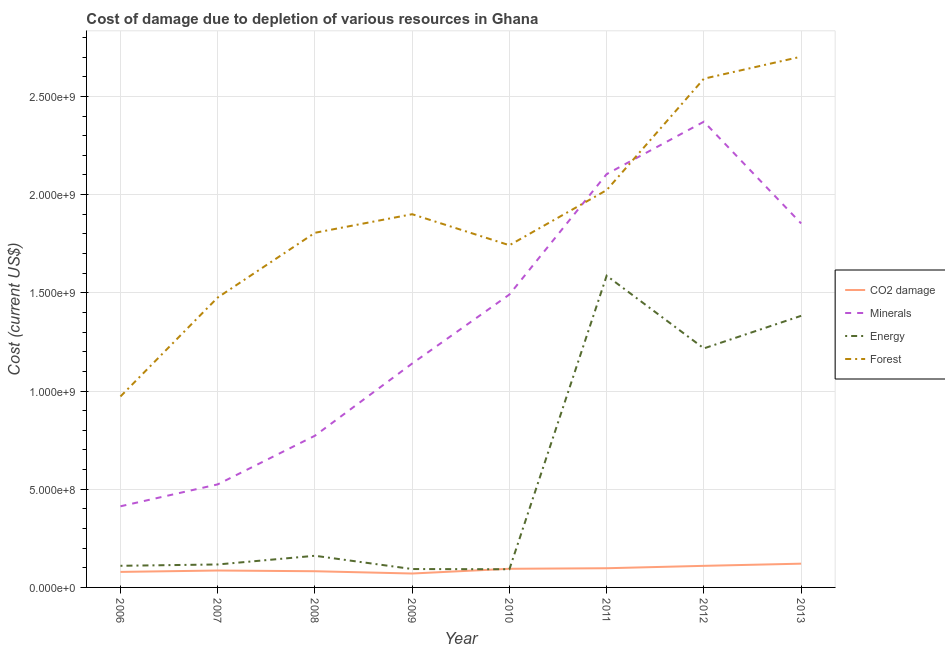How many different coloured lines are there?
Your answer should be compact. 4. Does the line corresponding to cost of damage due to depletion of coal intersect with the line corresponding to cost of damage due to depletion of forests?
Provide a succinct answer. No. Is the number of lines equal to the number of legend labels?
Provide a succinct answer. Yes. What is the cost of damage due to depletion of forests in 2013?
Provide a succinct answer. 2.70e+09. Across all years, what is the maximum cost of damage due to depletion of forests?
Your answer should be very brief. 2.70e+09. Across all years, what is the minimum cost of damage due to depletion of forests?
Provide a short and direct response. 9.72e+08. In which year was the cost of damage due to depletion of forests minimum?
Provide a succinct answer. 2006. What is the total cost of damage due to depletion of energy in the graph?
Provide a succinct answer. 4.76e+09. What is the difference between the cost of damage due to depletion of forests in 2008 and that in 2013?
Provide a short and direct response. -8.97e+08. What is the difference between the cost of damage due to depletion of minerals in 2006 and the cost of damage due to depletion of coal in 2013?
Your answer should be compact. 2.92e+08. What is the average cost of damage due to depletion of minerals per year?
Offer a terse response. 1.33e+09. In the year 2006, what is the difference between the cost of damage due to depletion of energy and cost of damage due to depletion of minerals?
Your response must be concise. -3.03e+08. What is the ratio of the cost of damage due to depletion of energy in 2008 to that in 2009?
Your answer should be compact. 1.72. Is the difference between the cost of damage due to depletion of coal in 2011 and 2013 greater than the difference between the cost of damage due to depletion of forests in 2011 and 2013?
Offer a terse response. Yes. What is the difference between the highest and the second highest cost of damage due to depletion of minerals?
Provide a short and direct response. 2.67e+08. What is the difference between the highest and the lowest cost of damage due to depletion of minerals?
Make the answer very short. 1.96e+09. Is the sum of the cost of damage due to depletion of energy in 2010 and 2012 greater than the maximum cost of damage due to depletion of forests across all years?
Your answer should be compact. No. Is it the case that in every year, the sum of the cost of damage due to depletion of energy and cost of damage due to depletion of minerals is greater than the sum of cost of damage due to depletion of coal and cost of damage due to depletion of forests?
Ensure brevity in your answer.  No. Is the cost of damage due to depletion of minerals strictly greater than the cost of damage due to depletion of coal over the years?
Your answer should be compact. Yes. Is the cost of damage due to depletion of minerals strictly less than the cost of damage due to depletion of energy over the years?
Provide a succinct answer. No. How many lines are there?
Give a very brief answer. 4. What is the difference between two consecutive major ticks on the Y-axis?
Give a very brief answer. 5.00e+08. Does the graph contain any zero values?
Provide a short and direct response. No. Does the graph contain grids?
Provide a short and direct response. Yes. Where does the legend appear in the graph?
Provide a succinct answer. Center right. How many legend labels are there?
Your answer should be very brief. 4. How are the legend labels stacked?
Your answer should be compact. Vertical. What is the title of the graph?
Ensure brevity in your answer.  Cost of damage due to depletion of various resources in Ghana . Does "Goods and services" appear as one of the legend labels in the graph?
Ensure brevity in your answer.  No. What is the label or title of the X-axis?
Ensure brevity in your answer.  Year. What is the label or title of the Y-axis?
Your answer should be compact. Cost (current US$). What is the Cost (current US$) in CO2 damage in 2006?
Provide a succinct answer. 7.90e+07. What is the Cost (current US$) of Minerals in 2006?
Your answer should be compact. 4.13e+08. What is the Cost (current US$) of Energy in 2006?
Provide a succinct answer. 1.10e+08. What is the Cost (current US$) of Forest in 2006?
Keep it short and to the point. 9.72e+08. What is the Cost (current US$) in CO2 damage in 2007?
Your response must be concise. 8.61e+07. What is the Cost (current US$) in Minerals in 2007?
Offer a terse response. 5.25e+08. What is the Cost (current US$) of Energy in 2007?
Offer a terse response. 1.17e+08. What is the Cost (current US$) of Forest in 2007?
Ensure brevity in your answer.  1.48e+09. What is the Cost (current US$) in CO2 damage in 2008?
Your answer should be very brief. 8.25e+07. What is the Cost (current US$) of Minerals in 2008?
Give a very brief answer. 7.72e+08. What is the Cost (current US$) in Energy in 2008?
Provide a succinct answer. 1.61e+08. What is the Cost (current US$) in Forest in 2008?
Ensure brevity in your answer.  1.81e+09. What is the Cost (current US$) in CO2 damage in 2009?
Your answer should be very brief. 7.08e+07. What is the Cost (current US$) in Minerals in 2009?
Your answer should be compact. 1.14e+09. What is the Cost (current US$) in Energy in 2009?
Your answer should be compact. 9.36e+07. What is the Cost (current US$) in Forest in 2009?
Give a very brief answer. 1.90e+09. What is the Cost (current US$) of CO2 damage in 2010?
Provide a short and direct response. 9.49e+07. What is the Cost (current US$) of Minerals in 2010?
Your answer should be very brief. 1.49e+09. What is the Cost (current US$) in Energy in 2010?
Your answer should be compact. 9.26e+07. What is the Cost (current US$) of Forest in 2010?
Your answer should be very brief. 1.74e+09. What is the Cost (current US$) of CO2 damage in 2011?
Your answer should be very brief. 9.77e+07. What is the Cost (current US$) in Minerals in 2011?
Your answer should be compact. 2.10e+09. What is the Cost (current US$) of Energy in 2011?
Your response must be concise. 1.59e+09. What is the Cost (current US$) in Forest in 2011?
Ensure brevity in your answer.  2.02e+09. What is the Cost (current US$) of CO2 damage in 2012?
Keep it short and to the point. 1.10e+08. What is the Cost (current US$) of Minerals in 2012?
Make the answer very short. 2.37e+09. What is the Cost (current US$) of Energy in 2012?
Provide a succinct answer. 1.22e+09. What is the Cost (current US$) in Forest in 2012?
Provide a succinct answer. 2.59e+09. What is the Cost (current US$) in CO2 damage in 2013?
Offer a very short reply. 1.21e+08. What is the Cost (current US$) in Minerals in 2013?
Offer a very short reply. 1.85e+09. What is the Cost (current US$) in Energy in 2013?
Make the answer very short. 1.38e+09. What is the Cost (current US$) of Forest in 2013?
Your response must be concise. 2.70e+09. Across all years, what is the maximum Cost (current US$) of CO2 damage?
Your response must be concise. 1.21e+08. Across all years, what is the maximum Cost (current US$) in Minerals?
Provide a succinct answer. 2.37e+09. Across all years, what is the maximum Cost (current US$) of Energy?
Offer a terse response. 1.59e+09. Across all years, what is the maximum Cost (current US$) in Forest?
Your response must be concise. 2.70e+09. Across all years, what is the minimum Cost (current US$) in CO2 damage?
Your response must be concise. 7.08e+07. Across all years, what is the minimum Cost (current US$) of Minerals?
Provide a succinct answer. 4.13e+08. Across all years, what is the minimum Cost (current US$) in Energy?
Your answer should be very brief. 9.26e+07. Across all years, what is the minimum Cost (current US$) of Forest?
Provide a short and direct response. 9.72e+08. What is the total Cost (current US$) of CO2 damage in the graph?
Offer a terse response. 7.42e+08. What is the total Cost (current US$) in Minerals in the graph?
Offer a very short reply. 1.07e+1. What is the total Cost (current US$) of Energy in the graph?
Keep it short and to the point. 4.76e+09. What is the total Cost (current US$) of Forest in the graph?
Your response must be concise. 1.52e+1. What is the difference between the Cost (current US$) in CO2 damage in 2006 and that in 2007?
Your answer should be compact. -7.07e+06. What is the difference between the Cost (current US$) of Minerals in 2006 and that in 2007?
Give a very brief answer. -1.12e+08. What is the difference between the Cost (current US$) in Energy in 2006 and that in 2007?
Give a very brief answer. -6.77e+06. What is the difference between the Cost (current US$) of Forest in 2006 and that in 2007?
Provide a short and direct response. -5.04e+08. What is the difference between the Cost (current US$) of CO2 damage in 2006 and that in 2008?
Ensure brevity in your answer.  -3.46e+06. What is the difference between the Cost (current US$) in Minerals in 2006 and that in 2008?
Ensure brevity in your answer.  -3.59e+08. What is the difference between the Cost (current US$) in Energy in 2006 and that in 2008?
Ensure brevity in your answer.  -5.10e+07. What is the difference between the Cost (current US$) of Forest in 2006 and that in 2008?
Offer a very short reply. -8.33e+08. What is the difference between the Cost (current US$) of CO2 damage in 2006 and that in 2009?
Provide a succinct answer. 8.18e+06. What is the difference between the Cost (current US$) of Minerals in 2006 and that in 2009?
Provide a succinct answer. -7.27e+08. What is the difference between the Cost (current US$) of Energy in 2006 and that in 2009?
Give a very brief answer. 1.65e+07. What is the difference between the Cost (current US$) in Forest in 2006 and that in 2009?
Provide a short and direct response. -9.28e+08. What is the difference between the Cost (current US$) of CO2 damage in 2006 and that in 2010?
Provide a succinct answer. -1.59e+07. What is the difference between the Cost (current US$) of Minerals in 2006 and that in 2010?
Your response must be concise. -1.08e+09. What is the difference between the Cost (current US$) in Energy in 2006 and that in 2010?
Provide a succinct answer. 1.76e+07. What is the difference between the Cost (current US$) in Forest in 2006 and that in 2010?
Provide a succinct answer. -7.70e+08. What is the difference between the Cost (current US$) in CO2 damage in 2006 and that in 2011?
Offer a terse response. -1.87e+07. What is the difference between the Cost (current US$) of Minerals in 2006 and that in 2011?
Make the answer very short. -1.69e+09. What is the difference between the Cost (current US$) in Energy in 2006 and that in 2011?
Make the answer very short. -1.48e+09. What is the difference between the Cost (current US$) in Forest in 2006 and that in 2011?
Make the answer very short. -1.05e+09. What is the difference between the Cost (current US$) of CO2 damage in 2006 and that in 2012?
Offer a very short reply. -3.08e+07. What is the difference between the Cost (current US$) in Minerals in 2006 and that in 2012?
Offer a terse response. -1.96e+09. What is the difference between the Cost (current US$) of Energy in 2006 and that in 2012?
Your answer should be very brief. -1.11e+09. What is the difference between the Cost (current US$) in Forest in 2006 and that in 2012?
Provide a succinct answer. -1.62e+09. What is the difference between the Cost (current US$) of CO2 damage in 2006 and that in 2013?
Make the answer very short. -4.19e+07. What is the difference between the Cost (current US$) in Minerals in 2006 and that in 2013?
Your answer should be very brief. -1.44e+09. What is the difference between the Cost (current US$) of Energy in 2006 and that in 2013?
Make the answer very short. -1.27e+09. What is the difference between the Cost (current US$) in Forest in 2006 and that in 2013?
Provide a succinct answer. -1.73e+09. What is the difference between the Cost (current US$) in CO2 damage in 2007 and that in 2008?
Offer a very short reply. 3.61e+06. What is the difference between the Cost (current US$) in Minerals in 2007 and that in 2008?
Make the answer very short. -2.48e+08. What is the difference between the Cost (current US$) of Energy in 2007 and that in 2008?
Keep it short and to the point. -4.42e+07. What is the difference between the Cost (current US$) of Forest in 2007 and that in 2008?
Offer a terse response. -3.30e+08. What is the difference between the Cost (current US$) in CO2 damage in 2007 and that in 2009?
Give a very brief answer. 1.52e+07. What is the difference between the Cost (current US$) in Minerals in 2007 and that in 2009?
Offer a very short reply. -6.15e+08. What is the difference between the Cost (current US$) of Energy in 2007 and that in 2009?
Your answer should be very brief. 2.33e+07. What is the difference between the Cost (current US$) of Forest in 2007 and that in 2009?
Your answer should be very brief. -4.24e+08. What is the difference between the Cost (current US$) in CO2 damage in 2007 and that in 2010?
Your response must be concise. -8.87e+06. What is the difference between the Cost (current US$) of Minerals in 2007 and that in 2010?
Provide a short and direct response. -9.67e+08. What is the difference between the Cost (current US$) in Energy in 2007 and that in 2010?
Offer a very short reply. 2.43e+07. What is the difference between the Cost (current US$) of Forest in 2007 and that in 2010?
Your response must be concise. -2.66e+08. What is the difference between the Cost (current US$) in CO2 damage in 2007 and that in 2011?
Offer a terse response. -1.16e+07. What is the difference between the Cost (current US$) of Minerals in 2007 and that in 2011?
Ensure brevity in your answer.  -1.58e+09. What is the difference between the Cost (current US$) of Energy in 2007 and that in 2011?
Your answer should be very brief. -1.47e+09. What is the difference between the Cost (current US$) in Forest in 2007 and that in 2011?
Ensure brevity in your answer.  -5.47e+08. What is the difference between the Cost (current US$) of CO2 damage in 2007 and that in 2012?
Your response must be concise. -2.38e+07. What is the difference between the Cost (current US$) in Minerals in 2007 and that in 2012?
Give a very brief answer. -1.85e+09. What is the difference between the Cost (current US$) in Energy in 2007 and that in 2012?
Keep it short and to the point. -1.10e+09. What is the difference between the Cost (current US$) in Forest in 2007 and that in 2012?
Your answer should be very brief. -1.11e+09. What is the difference between the Cost (current US$) of CO2 damage in 2007 and that in 2013?
Keep it short and to the point. -3.48e+07. What is the difference between the Cost (current US$) in Minerals in 2007 and that in 2013?
Keep it short and to the point. -1.33e+09. What is the difference between the Cost (current US$) of Energy in 2007 and that in 2013?
Provide a succinct answer. -1.27e+09. What is the difference between the Cost (current US$) in Forest in 2007 and that in 2013?
Your answer should be compact. -1.23e+09. What is the difference between the Cost (current US$) of CO2 damage in 2008 and that in 2009?
Keep it short and to the point. 1.16e+07. What is the difference between the Cost (current US$) of Minerals in 2008 and that in 2009?
Give a very brief answer. -3.68e+08. What is the difference between the Cost (current US$) in Energy in 2008 and that in 2009?
Ensure brevity in your answer.  6.75e+07. What is the difference between the Cost (current US$) of Forest in 2008 and that in 2009?
Your answer should be very brief. -9.46e+07. What is the difference between the Cost (current US$) in CO2 damage in 2008 and that in 2010?
Provide a succinct answer. -1.25e+07. What is the difference between the Cost (current US$) in Minerals in 2008 and that in 2010?
Provide a succinct answer. -7.19e+08. What is the difference between the Cost (current US$) of Energy in 2008 and that in 2010?
Provide a short and direct response. 6.85e+07. What is the difference between the Cost (current US$) in Forest in 2008 and that in 2010?
Provide a short and direct response. 6.34e+07. What is the difference between the Cost (current US$) of CO2 damage in 2008 and that in 2011?
Your answer should be compact. -1.52e+07. What is the difference between the Cost (current US$) in Minerals in 2008 and that in 2011?
Ensure brevity in your answer.  -1.33e+09. What is the difference between the Cost (current US$) of Energy in 2008 and that in 2011?
Offer a very short reply. -1.43e+09. What is the difference between the Cost (current US$) of Forest in 2008 and that in 2011?
Give a very brief answer. -2.17e+08. What is the difference between the Cost (current US$) in CO2 damage in 2008 and that in 2012?
Keep it short and to the point. -2.74e+07. What is the difference between the Cost (current US$) of Minerals in 2008 and that in 2012?
Your answer should be very brief. -1.60e+09. What is the difference between the Cost (current US$) of Energy in 2008 and that in 2012?
Offer a terse response. -1.06e+09. What is the difference between the Cost (current US$) in Forest in 2008 and that in 2012?
Offer a very short reply. -7.84e+08. What is the difference between the Cost (current US$) of CO2 damage in 2008 and that in 2013?
Your response must be concise. -3.85e+07. What is the difference between the Cost (current US$) of Minerals in 2008 and that in 2013?
Offer a terse response. -1.08e+09. What is the difference between the Cost (current US$) of Energy in 2008 and that in 2013?
Provide a short and direct response. -1.22e+09. What is the difference between the Cost (current US$) in Forest in 2008 and that in 2013?
Keep it short and to the point. -8.97e+08. What is the difference between the Cost (current US$) of CO2 damage in 2009 and that in 2010?
Your answer should be compact. -2.41e+07. What is the difference between the Cost (current US$) in Minerals in 2009 and that in 2010?
Provide a short and direct response. -3.51e+08. What is the difference between the Cost (current US$) in Energy in 2009 and that in 2010?
Your answer should be compact. 1.07e+06. What is the difference between the Cost (current US$) in Forest in 2009 and that in 2010?
Provide a short and direct response. 1.58e+08. What is the difference between the Cost (current US$) in CO2 damage in 2009 and that in 2011?
Offer a terse response. -2.69e+07. What is the difference between the Cost (current US$) of Minerals in 2009 and that in 2011?
Offer a very short reply. -9.64e+08. What is the difference between the Cost (current US$) in Energy in 2009 and that in 2011?
Give a very brief answer. -1.49e+09. What is the difference between the Cost (current US$) in Forest in 2009 and that in 2011?
Offer a very short reply. -1.23e+08. What is the difference between the Cost (current US$) of CO2 damage in 2009 and that in 2012?
Provide a short and direct response. -3.90e+07. What is the difference between the Cost (current US$) of Minerals in 2009 and that in 2012?
Make the answer very short. -1.23e+09. What is the difference between the Cost (current US$) of Energy in 2009 and that in 2012?
Offer a very short reply. -1.12e+09. What is the difference between the Cost (current US$) of Forest in 2009 and that in 2012?
Make the answer very short. -6.90e+08. What is the difference between the Cost (current US$) in CO2 damage in 2009 and that in 2013?
Provide a succinct answer. -5.01e+07. What is the difference between the Cost (current US$) of Minerals in 2009 and that in 2013?
Offer a terse response. -7.13e+08. What is the difference between the Cost (current US$) of Energy in 2009 and that in 2013?
Make the answer very short. -1.29e+09. What is the difference between the Cost (current US$) in Forest in 2009 and that in 2013?
Provide a short and direct response. -8.02e+08. What is the difference between the Cost (current US$) in CO2 damage in 2010 and that in 2011?
Make the answer very short. -2.77e+06. What is the difference between the Cost (current US$) in Minerals in 2010 and that in 2011?
Offer a very short reply. -6.13e+08. What is the difference between the Cost (current US$) in Energy in 2010 and that in 2011?
Your answer should be very brief. -1.49e+09. What is the difference between the Cost (current US$) of Forest in 2010 and that in 2011?
Give a very brief answer. -2.81e+08. What is the difference between the Cost (current US$) in CO2 damage in 2010 and that in 2012?
Keep it short and to the point. -1.49e+07. What is the difference between the Cost (current US$) of Minerals in 2010 and that in 2012?
Give a very brief answer. -8.80e+08. What is the difference between the Cost (current US$) of Energy in 2010 and that in 2012?
Offer a very short reply. -1.12e+09. What is the difference between the Cost (current US$) in Forest in 2010 and that in 2012?
Your answer should be compact. -8.48e+08. What is the difference between the Cost (current US$) in CO2 damage in 2010 and that in 2013?
Offer a terse response. -2.60e+07. What is the difference between the Cost (current US$) in Minerals in 2010 and that in 2013?
Provide a succinct answer. -3.62e+08. What is the difference between the Cost (current US$) of Energy in 2010 and that in 2013?
Your answer should be compact. -1.29e+09. What is the difference between the Cost (current US$) of Forest in 2010 and that in 2013?
Ensure brevity in your answer.  -9.60e+08. What is the difference between the Cost (current US$) in CO2 damage in 2011 and that in 2012?
Your answer should be compact. -1.21e+07. What is the difference between the Cost (current US$) of Minerals in 2011 and that in 2012?
Offer a very short reply. -2.67e+08. What is the difference between the Cost (current US$) of Energy in 2011 and that in 2012?
Offer a terse response. 3.70e+08. What is the difference between the Cost (current US$) of Forest in 2011 and that in 2012?
Ensure brevity in your answer.  -5.67e+08. What is the difference between the Cost (current US$) of CO2 damage in 2011 and that in 2013?
Provide a succinct answer. -2.32e+07. What is the difference between the Cost (current US$) of Minerals in 2011 and that in 2013?
Keep it short and to the point. 2.51e+08. What is the difference between the Cost (current US$) of Energy in 2011 and that in 2013?
Provide a short and direct response. 2.04e+08. What is the difference between the Cost (current US$) in Forest in 2011 and that in 2013?
Provide a succinct answer. -6.79e+08. What is the difference between the Cost (current US$) in CO2 damage in 2012 and that in 2013?
Offer a terse response. -1.11e+07. What is the difference between the Cost (current US$) of Minerals in 2012 and that in 2013?
Provide a succinct answer. 5.18e+08. What is the difference between the Cost (current US$) in Energy in 2012 and that in 2013?
Your response must be concise. -1.66e+08. What is the difference between the Cost (current US$) in Forest in 2012 and that in 2013?
Offer a terse response. -1.12e+08. What is the difference between the Cost (current US$) in CO2 damage in 2006 and the Cost (current US$) in Minerals in 2007?
Provide a short and direct response. -4.46e+08. What is the difference between the Cost (current US$) of CO2 damage in 2006 and the Cost (current US$) of Energy in 2007?
Your response must be concise. -3.79e+07. What is the difference between the Cost (current US$) of CO2 damage in 2006 and the Cost (current US$) of Forest in 2007?
Your response must be concise. -1.40e+09. What is the difference between the Cost (current US$) in Minerals in 2006 and the Cost (current US$) in Energy in 2007?
Make the answer very short. 2.96e+08. What is the difference between the Cost (current US$) in Minerals in 2006 and the Cost (current US$) in Forest in 2007?
Ensure brevity in your answer.  -1.06e+09. What is the difference between the Cost (current US$) of Energy in 2006 and the Cost (current US$) of Forest in 2007?
Your answer should be compact. -1.37e+09. What is the difference between the Cost (current US$) of CO2 damage in 2006 and the Cost (current US$) of Minerals in 2008?
Provide a short and direct response. -6.93e+08. What is the difference between the Cost (current US$) of CO2 damage in 2006 and the Cost (current US$) of Energy in 2008?
Your answer should be compact. -8.21e+07. What is the difference between the Cost (current US$) of CO2 damage in 2006 and the Cost (current US$) of Forest in 2008?
Your answer should be compact. -1.73e+09. What is the difference between the Cost (current US$) of Minerals in 2006 and the Cost (current US$) of Energy in 2008?
Ensure brevity in your answer.  2.52e+08. What is the difference between the Cost (current US$) in Minerals in 2006 and the Cost (current US$) in Forest in 2008?
Your answer should be very brief. -1.39e+09. What is the difference between the Cost (current US$) in Energy in 2006 and the Cost (current US$) in Forest in 2008?
Provide a short and direct response. -1.70e+09. What is the difference between the Cost (current US$) in CO2 damage in 2006 and the Cost (current US$) in Minerals in 2009?
Make the answer very short. -1.06e+09. What is the difference between the Cost (current US$) of CO2 damage in 2006 and the Cost (current US$) of Energy in 2009?
Your answer should be compact. -1.46e+07. What is the difference between the Cost (current US$) of CO2 damage in 2006 and the Cost (current US$) of Forest in 2009?
Provide a succinct answer. -1.82e+09. What is the difference between the Cost (current US$) in Minerals in 2006 and the Cost (current US$) in Energy in 2009?
Your answer should be compact. 3.19e+08. What is the difference between the Cost (current US$) of Minerals in 2006 and the Cost (current US$) of Forest in 2009?
Provide a succinct answer. -1.49e+09. What is the difference between the Cost (current US$) of Energy in 2006 and the Cost (current US$) of Forest in 2009?
Provide a succinct answer. -1.79e+09. What is the difference between the Cost (current US$) of CO2 damage in 2006 and the Cost (current US$) of Minerals in 2010?
Provide a short and direct response. -1.41e+09. What is the difference between the Cost (current US$) in CO2 damage in 2006 and the Cost (current US$) in Energy in 2010?
Your answer should be compact. -1.36e+07. What is the difference between the Cost (current US$) of CO2 damage in 2006 and the Cost (current US$) of Forest in 2010?
Make the answer very short. -1.66e+09. What is the difference between the Cost (current US$) of Minerals in 2006 and the Cost (current US$) of Energy in 2010?
Keep it short and to the point. 3.20e+08. What is the difference between the Cost (current US$) in Minerals in 2006 and the Cost (current US$) in Forest in 2010?
Make the answer very short. -1.33e+09. What is the difference between the Cost (current US$) in Energy in 2006 and the Cost (current US$) in Forest in 2010?
Ensure brevity in your answer.  -1.63e+09. What is the difference between the Cost (current US$) of CO2 damage in 2006 and the Cost (current US$) of Minerals in 2011?
Provide a short and direct response. -2.03e+09. What is the difference between the Cost (current US$) in CO2 damage in 2006 and the Cost (current US$) in Energy in 2011?
Keep it short and to the point. -1.51e+09. What is the difference between the Cost (current US$) of CO2 damage in 2006 and the Cost (current US$) of Forest in 2011?
Your answer should be compact. -1.94e+09. What is the difference between the Cost (current US$) of Minerals in 2006 and the Cost (current US$) of Energy in 2011?
Provide a succinct answer. -1.17e+09. What is the difference between the Cost (current US$) of Minerals in 2006 and the Cost (current US$) of Forest in 2011?
Your answer should be compact. -1.61e+09. What is the difference between the Cost (current US$) of Energy in 2006 and the Cost (current US$) of Forest in 2011?
Your response must be concise. -1.91e+09. What is the difference between the Cost (current US$) in CO2 damage in 2006 and the Cost (current US$) in Minerals in 2012?
Offer a terse response. -2.29e+09. What is the difference between the Cost (current US$) of CO2 damage in 2006 and the Cost (current US$) of Energy in 2012?
Provide a short and direct response. -1.14e+09. What is the difference between the Cost (current US$) in CO2 damage in 2006 and the Cost (current US$) in Forest in 2012?
Your response must be concise. -2.51e+09. What is the difference between the Cost (current US$) in Minerals in 2006 and the Cost (current US$) in Energy in 2012?
Your answer should be very brief. -8.04e+08. What is the difference between the Cost (current US$) in Minerals in 2006 and the Cost (current US$) in Forest in 2012?
Provide a succinct answer. -2.18e+09. What is the difference between the Cost (current US$) of Energy in 2006 and the Cost (current US$) of Forest in 2012?
Ensure brevity in your answer.  -2.48e+09. What is the difference between the Cost (current US$) of CO2 damage in 2006 and the Cost (current US$) of Minerals in 2013?
Offer a terse response. -1.77e+09. What is the difference between the Cost (current US$) in CO2 damage in 2006 and the Cost (current US$) in Energy in 2013?
Your answer should be compact. -1.30e+09. What is the difference between the Cost (current US$) of CO2 damage in 2006 and the Cost (current US$) of Forest in 2013?
Your answer should be very brief. -2.62e+09. What is the difference between the Cost (current US$) in Minerals in 2006 and the Cost (current US$) in Energy in 2013?
Offer a terse response. -9.70e+08. What is the difference between the Cost (current US$) in Minerals in 2006 and the Cost (current US$) in Forest in 2013?
Your response must be concise. -2.29e+09. What is the difference between the Cost (current US$) of Energy in 2006 and the Cost (current US$) of Forest in 2013?
Your answer should be very brief. -2.59e+09. What is the difference between the Cost (current US$) of CO2 damage in 2007 and the Cost (current US$) of Minerals in 2008?
Keep it short and to the point. -6.86e+08. What is the difference between the Cost (current US$) of CO2 damage in 2007 and the Cost (current US$) of Energy in 2008?
Provide a short and direct response. -7.50e+07. What is the difference between the Cost (current US$) of CO2 damage in 2007 and the Cost (current US$) of Forest in 2008?
Give a very brief answer. -1.72e+09. What is the difference between the Cost (current US$) in Minerals in 2007 and the Cost (current US$) in Energy in 2008?
Offer a terse response. 3.64e+08. What is the difference between the Cost (current US$) of Minerals in 2007 and the Cost (current US$) of Forest in 2008?
Keep it short and to the point. -1.28e+09. What is the difference between the Cost (current US$) in Energy in 2007 and the Cost (current US$) in Forest in 2008?
Your answer should be compact. -1.69e+09. What is the difference between the Cost (current US$) of CO2 damage in 2007 and the Cost (current US$) of Minerals in 2009?
Give a very brief answer. -1.05e+09. What is the difference between the Cost (current US$) in CO2 damage in 2007 and the Cost (current US$) in Energy in 2009?
Keep it short and to the point. -7.57e+06. What is the difference between the Cost (current US$) in CO2 damage in 2007 and the Cost (current US$) in Forest in 2009?
Make the answer very short. -1.81e+09. What is the difference between the Cost (current US$) of Minerals in 2007 and the Cost (current US$) of Energy in 2009?
Provide a succinct answer. 4.31e+08. What is the difference between the Cost (current US$) of Minerals in 2007 and the Cost (current US$) of Forest in 2009?
Your answer should be compact. -1.38e+09. What is the difference between the Cost (current US$) in Energy in 2007 and the Cost (current US$) in Forest in 2009?
Offer a very short reply. -1.78e+09. What is the difference between the Cost (current US$) of CO2 damage in 2007 and the Cost (current US$) of Minerals in 2010?
Ensure brevity in your answer.  -1.41e+09. What is the difference between the Cost (current US$) of CO2 damage in 2007 and the Cost (current US$) of Energy in 2010?
Offer a very short reply. -6.50e+06. What is the difference between the Cost (current US$) of CO2 damage in 2007 and the Cost (current US$) of Forest in 2010?
Keep it short and to the point. -1.66e+09. What is the difference between the Cost (current US$) of Minerals in 2007 and the Cost (current US$) of Energy in 2010?
Offer a terse response. 4.32e+08. What is the difference between the Cost (current US$) in Minerals in 2007 and the Cost (current US$) in Forest in 2010?
Provide a short and direct response. -1.22e+09. What is the difference between the Cost (current US$) of Energy in 2007 and the Cost (current US$) of Forest in 2010?
Give a very brief answer. -1.63e+09. What is the difference between the Cost (current US$) in CO2 damage in 2007 and the Cost (current US$) in Minerals in 2011?
Provide a succinct answer. -2.02e+09. What is the difference between the Cost (current US$) of CO2 damage in 2007 and the Cost (current US$) of Energy in 2011?
Provide a succinct answer. -1.50e+09. What is the difference between the Cost (current US$) of CO2 damage in 2007 and the Cost (current US$) of Forest in 2011?
Give a very brief answer. -1.94e+09. What is the difference between the Cost (current US$) of Minerals in 2007 and the Cost (current US$) of Energy in 2011?
Provide a succinct answer. -1.06e+09. What is the difference between the Cost (current US$) in Minerals in 2007 and the Cost (current US$) in Forest in 2011?
Provide a short and direct response. -1.50e+09. What is the difference between the Cost (current US$) of Energy in 2007 and the Cost (current US$) of Forest in 2011?
Make the answer very short. -1.91e+09. What is the difference between the Cost (current US$) in CO2 damage in 2007 and the Cost (current US$) in Minerals in 2012?
Provide a succinct answer. -2.29e+09. What is the difference between the Cost (current US$) of CO2 damage in 2007 and the Cost (current US$) of Energy in 2012?
Ensure brevity in your answer.  -1.13e+09. What is the difference between the Cost (current US$) of CO2 damage in 2007 and the Cost (current US$) of Forest in 2012?
Your answer should be very brief. -2.50e+09. What is the difference between the Cost (current US$) of Minerals in 2007 and the Cost (current US$) of Energy in 2012?
Offer a terse response. -6.92e+08. What is the difference between the Cost (current US$) in Minerals in 2007 and the Cost (current US$) in Forest in 2012?
Ensure brevity in your answer.  -2.07e+09. What is the difference between the Cost (current US$) in Energy in 2007 and the Cost (current US$) in Forest in 2012?
Keep it short and to the point. -2.47e+09. What is the difference between the Cost (current US$) in CO2 damage in 2007 and the Cost (current US$) in Minerals in 2013?
Ensure brevity in your answer.  -1.77e+09. What is the difference between the Cost (current US$) in CO2 damage in 2007 and the Cost (current US$) in Energy in 2013?
Provide a succinct answer. -1.30e+09. What is the difference between the Cost (current US$) in CO2 damage in 2007 and the Cost (current US$) in Forest in 2013?
Provide a short and direct response. -2.62e+09. What is the difference between the Cost (current US$) of Minerals in 2007 and the Cost (current US$) of Energy in 2013?
Provide a short and direct response. -8.58e+08. What is the difference between the Cost (current US$) in Minerals in 2007 and the Cost (current US$) in Forest in 2013?
Make the answer very short. -2.18e+09. What is the difference between the Cost (current US$) of Energy in 2007 and the Cost (current US$) of Forest in 2013?
Ensure brevity in your answer.  -2.59e+09. What is the difference between the Cost (current US$) in CO2 damage in 2008 and the Cost (current US$) in Minerals in 2009?
Give a very brief answer. -1.06e+09. What is the difference between the Cost (current US$) in CO2 damage in 2008 and the Cost (current US$) in Energy in 2009?
Your response must be concise. -1.12e+07. What is the difference between the Cost (current US$) of CO2 damage in 2008 and the Cost (current US$) of Forest in 2009?
Your answer should be very brief. -1.82e+09. What is the difference between the Cost (current US$) in Minerals in 2008 and the Cost (current US$) in Energy in 2009?
Ensure brevity in your answer.  6.79e+08. What is the difference between the Cost (current US$) in Minerals in 2008 and the Cost (current US$) in Forest in 2009?
Keep it short and to the point. -1.13e+09. What is the difference between the Cost (current US$) in Energy in 2008 and the Cost (current US$) in Forest in 2009?
Your response must be concise. -1.74e+09. What is the difference between the Cost (current US$) in CO2 damage in 2008 and the Cost (current US$) in Minerals in 2010?
Your answer should be compact. -1.41e+09. What is the difference between the Cost (current US$) in CO2 damage in 2008 and the Cost (current US$) in Energy in 2010?
Ensure brevity in your answer.  -1.01e+07. What is the difference between the Cost (current US$) in CO2 damage in 2008 and the Cost (current US$) in Forest in 2010?
Provide a succinct answer. -1.66e+09. What is the difference between the Cost (current US$) in Minerals in 2008 and the Cost (current US$) in Energy in 2010?
Keep it short and to the point. 6.80e+08. What is the difference between the Cost (current US$) in Minerals in 2008 and the Cost (current US$) in Forest in 2010?
Offer a terse response. -9.70e+08. What is the difference between the Cost (current US$) in Energy in 2008 and the Cost (current US$) in Forest in 2010?
Provide a short and direct response. -1.58e+09. What is the difference between the Cost (current US$) in CO2 damage in 2008 and the Cost (current US$) in Minerals in 2011?
Offer a terse response. -2.02e+09. What is the difference between the Cost (current US$) of CO2 damage in 2008 and the Cost (current US$) of Energy in 2011?
Offer a very short reply. -1.50e+09. What is the difference between the Cost (current US$) in CO2 damage in 2008 and the Cost (current US$) in Forest in 2011?
Offer a terse response. -1.94e+09. What is the difference between the Cost (current US$) of Minerals in 2008 and the Cost (current US$) of Energy in 2011?
Your answer should be compact. -8.15e+08. What is the difference between the Cost (current US$) in Minerals in 2008 and the Cost (current US$) in Forest in 2011?
Ensure brevity in your answer.  -1.25e+09. What is the difference between the Cost (current US$) of Energy in 2008 and the Cost (current US$) of Forest in 2011?
Ensure brevity in your answer.  -1.86e+09. What is the difference between the Cost (current US$) in CO2 damage in 2008 and the Cost (current US$) in Minerals in 2012?
Your answer should be very brief. -2.29e+09. What is the difference between the Cost (current US$) of CO2 damage in 2008 and the Cost (current US$) of Energy in 2012?
Offer a very short reply. -1.13e+09. What is the difference between the Cost (current US$) of CO2 damage in 2008 and the Cost (current US$) of Forest in 2012?
Offer a very short reply. -2.51e+09. What is the difference between the Cost (current US$) in Minerals in 2008 and the Cost (current US$) in Energy in 2012?
Your answer should be very brief. -4.45e+08. What is the difference between the Cost (current US$) of Minerals in 2008 and the Cost (current US$) of Forest in 2012?
Your answer should be very brief. -1.82e+09. What is the difference between the Cost (current US$) in Energy in 2008 and the Cost (current US$) in Forest in 2012?
Your answer should be very brief. -2.43e+09. What is the difference between the Cost (current US$) of CO2 damage in 2008 and the Cost (current US$) of Minerals in 2013?
Provide a short and direct response. -1.77e+09. What is the difference between the Cost (current US$) in CO2 damage in 2008 and the Cost (current US$) in Energy in 2013?
Your answer should be very brief. -1.30e+09. What is the difference between the Cost (current US$) in CO2 damage in 2008 and the Cost (current US$) in Forest in 2013?
Offer a terse response. -2.62e+09. What is the difference between the Cost (current US$) in Minerals in 2008 and the Cost (current US$) in Energy in 2013?
Make the answer very short. -6.10e+08. What is the difference between the Cost (current US$) in Minerals in 2008 and the Cost (current US$) in Forest in 2013?
Your response must be concise. -1.93e+09. What is the difference between the Cost (current US$) of Energy in 2008 and the Cost (current US$) of Forest in 2013?
Your response must be concise. -2.54e+09. What is the difference between the Cost (current US$) in CO2 damage in 2009 and the Cost (current US$) in Minerals in 2010?
Make the answer very short. -1.42e+09. What is the difference between the Cost (current US$) of CO2 damage in 2009 and the Cost (current US$) of Energy in 2010?
Keep it short and to the point. -2.18e+07. What is the difference between the Cost (current US$) of CO2 damage in 2009 and the Cost (current US$) of Forest in 2010?
Give a very brief answer. -1.67e+09. What is the difference between the Cost (current US$) in Minerals in 2009 and the Cost (current US$) in Energy in 2010?
Your response must be concise. 1.05e+09. What is the difference between the Cost (current US$) in Minerals in 2009 and the Cost (current US$) in Forest in 2010?
Ensure brevity in your answer.  -6.02e+08. What is the difference between the Cost (current US$) in Energy in 2009 and the Cost (current US$) in Forest in 2010?
Offer a terse response. -1.65e+09. What is the difference between the Cost (current US$) in CO2 damage in 2009 and the Cost (current US$) in Minerals in 2011?
Your response must be concise. -2.03e+09. What is the difference between the Cost (current US$) in CO2 damage in 2009 and the Cost (current US$) in Energy in 2011?
Your response must be concise. -1.52e+09. What is the difference between the Cost (current US$) in CO2 damage in 2009 and the Cost (current US$) in Forest in 2011?
Offer a very short reply. -1.95e+09. What is the difference between the Cost (current US$) of Minerals in 2009 and the Cost (current US$) of Energy in 2011?
Your answer should be compact. -4.47e+08. What is the difference between the Cost (current US$) in Minerals in 2009 and the Cost (current US$) in Forest in 2011?
Offer a terse response. -8.83e+08. What is the difference between the Cost (current US$) in Energy in 2009 and the Cost (current US$) in Forest in 2011?
Keep it short and to the point. -1.93e+09. What is the difference between the Cost (current US$) in CO2 damage in 2009 and the Cost (current US$) in Minerals in 2012?
Offer a terse response. -2.30e+09. What is the difference between the Cost (current US$) of CO2 damage in 2009 and the Cost (current US$) of Energy in 2012?
Your answer should be compact. -1.15e+09. What is the difference between the Cost (current US$) of CO2 damage in 2009 and the Cost (current US$) of Forest in 2012?
Your response must be concise. -2.52e+09. What is the difference between the Cost (current US$) of Minerals in 2009 and the Cost (current US$) of Energy in 2012?
Give a very brief answer. -7.69e+07. What is the difference between the Cost (current US$) in Minerals in 2009 and the Cost (current US$) in Forest in 2012?
Provide a succinct answer. -1.45e+09. What is the difference between the Cost (current US$) in Energy in 2009 and the Cost (current US$) in Forest in 2012?
Your answer should be compact. -2.50e+09. What is the difference between the Cost (current US$) in CO2 damage in 2009 and the Cost (current US$) in Minerals in 2013?
Your answer should be compact. -1.78e+09. What is the difference between the Cost (current US$) in CO2 damage in 2009 and the Cost (current US$) in Energy in 2013?
Provide a succinct answer. -1.31e+09. What is the difference between the Cost (current US$) of CO2 damage in 2009 and the Cost (current US$) of Forest in 2013?
Ensure brevity in your answer.  -2.63e+09. What is the difference between the Cost (current US$) of Minerals in 2009 and the Cost (current US$) of Energy in 2013?
Your answer should be compact. -2.43e+08. What is the difference between the Cost (current US$) in Minerals in 2009 and the Cost (current US$) in Forest in 2013?
Give a very brief answer. -1.56e+09. What is the difference between the Cost (current US$) of Energy in 2009 and the Cost (current US$) of Forest in 2013?
Your answer should be compact. -2.61e+09. What is the difference between the Cost (current US$) in CO2 damage in 2010 and the Cost (current US$) in Minerals in 2011?
Your answer should be compact. -2.01e+09. What is the difference between the Cost (current US$) of CO2 damage in 2010 and the Cost (current US$) of Energy in 2011?
Offer a very short reply. -1.49e+09. What is the difference between the Cost (current US$) in CO2 damage in 2010 and the Cost (current US$) in Forest in 2011?
Your answer should be very brief. -1.93e+09. What is the difference between the Cost (current US$) in Minerals in 2010 and the Cost (current US$) in Energy in 2011?
Provide a succinct answer. -9.58e+07. What is the difference between the Cost (current US$) of Minerals in 2010 and the Cost (current US$) of Forest in 2011?
Offer a terse response. -5.32e+08. What is the difference between the Cost (current US$) of Energy in 2010 and the Cost (current US$) of Forest in 2011?
Your answer should be very brief. -1.93e+09. What is the difference between the Cost (current US$) in CO2 damage in 2010 and the Cost (current US$) in Minerals in 2012?
Keep it short and to the point. -2.28e+09. What is the difference between the Cost (current US$) of CO2 damage in 2010 and the Cost (current US$) of Energy in 2012?
Your answer should be very brief. -1.12e+09. What is the difference between the Cost (current US$) of CO2 damage in 2010 and the Cost (current US$) of Forest in 2012?
Provide a short and direct response. -2.50e+09. What is the difference between the Cost (current US$) in Minerals in 2010 and the Cost (current US$) in Energy in 2012?
Your response must be concise. 2.74e+08. What is the difference between the Cost (current US$) in Minerals in 2010 and the Cost (current US$) in Forest in 2012?
Make the answer very short. -1.10e+09. What is the difference between the Cost (current US$) in Energy in 2010 and the Cost (current US$) in Forest in 2012?
Offer a very short reply. -2.50e+09. What is the difference between the Cost (current US$) of CO2 damage in 2010 and the Cost (current US$) of Minerals in 2013?
Your response must be concise. -1.76e+09. What is the difference between the Cost (current US$) of CO2 damage in 2010 and the Cost (current US$) of Energy in 2013?
Provide a short and direct response. -1.29e+09. What is the difference between the Cost (current US$) in CO2 damage in 2010 and the Cost (current US$) in Forest in 2013?
Provide a short and direct response. -2.61e+09. What is the difference between the Cost (current US$) of Minerals in 2010 and the Cost (current US$) of Energy in 2013?
Make the answer very short. 1.09e+08. What is the difference between the Cost (current US$) in Minerals in 2010 and the Cost (current US$) in Forest in 2013?
Offer a terse response. -1.21e+09. What is the difference between the Cost (current US$) of Energy in 2010 and the Cost (current US$) of Forest in 2013?
Offer a terse response. -2.61e+09. What is the difference between the Cost (current US$) in CO2 damage in 2011 and the Cost (current US$) in Minerals in 2012?
Give a very brief answer. -2.27e+09. What is the difference between the Cost (current US$) in CO2 damage in 2011 and the Cost (current US$) in Energy in 2012?
Give a very brief answer. -1.12e+09. What is the difference between the Cost (current US$) in CO2 damage in 2011 and the Cost (current US$) in Forest in 2012?
Provide a succinct answer. -2.49e+09. What is the difference between the Cost (current US$) of Minerals in 2011 and the Cost (current US$) of Energy in 2012?
Give a very brief answer. 8.87e+08. What is the difference between the Cost (current US$) of Minerals in 2011 and the Cost (current US$) of Forest in 2012?
Make the answer very short. -4.86e+08. What is the difference between the Cost (current US$) in Energy in 2011 and the Cost (current US$) in Forest in 2012?
Your response must be concise. -1.00e+09. What is the difference between the Cost (current US$) of CO2 damage in 2011 and the Cost (current US$) of Minerals in 2013?
Provide a succinct answer. -1.76e+09. What is the difference between the Cost (current US$) of CO2 damage in 2011 and the Cost (current US$) of Energy in 2013?
Provide a succinct answer. -1.29e+09. What is the difference between the Cost (current US$) in CO2 damage in 2011 and the Cost (current US$) in Forest in 2013?
Your answer should be compact. -2.60e+09. What is the difference between the Cost (current US$) of Minerals in 2011 and the Cost (current US$) of Energy in 2013?
Give a very brief answer. 7.22e+08. What is the difference between the Cost (current US$) in Minerals in 2011 and the Cost (current US$) in Forest in 2013?
Keep it short and to the point. -5.98e+08. What is the difference between the Cost (current US$) of Energy in 2011 and the Cost (current US$) of Forest in 2013?
Ensure brevity in your answer.  -1.12e+09. What is the difference between the Cost (current US$) in CO2 damage in 2012 and the Cost (current US$) in Minerals in 2013?
Provide a short and direct response. -1.74e+09. What is the difference between the Cost (current US$) in CO2 damage in 2012 and the Cost (current US$) in Energy in 2013?
Offer a very short reply. -1.27e+09. What is the difference between the Cost (current US$) in CO2 damage in 2012 and the Cost (current US$) in Forest in 2013?
Your response must be concise. -2.59e+09. What is the difference between the Cost (current US$) in Minerals in 2012 and the Cost (current US$) in Energy in 2013?
Provide a succinct answer. 9.88e+08. What is the difference between the Cost (current US$) in Minerals in 2012 and the Cost (current US$) in Forest in 2013?
Provide a succinct answer. -3.31e+08. What is the difference between the Cost (current US$) of Energy in 2012 and the Cost (current US$) of Forest in 2013?
Provide a succinct answer. -1.49e+09. What is the average Cost (current US$) of CO2 damage per year?
Keep it short and to the point. 9.27e+07. What is the average Cost (current US$) in Minerals per year?
Make the answer very short. 1.33e+09. What is the average Cost (current US$) of Energy per year?
Provide a succinct answer. 5.95e+08. What is the average Cost (current US$) in Forest per year?
Your answer should be very brief. 1.90e+09. In the year 2006, what is the difference between the Cost (current US$) of CO2 damage and Cost (current US$) of Minerals?
Offer a very short reply. -3.34e+08. In the year 2006, what is the difference between the Cost (current US$) of CO2 damage and Cost (current US$) of Energy?
Offer a terse response. -3.11e+07. In the year 2006, what is the difference between the Cost (current US$) in CO2 damage and Cost (current US$) in Forest?
Make the answer very short. -8.93e+08. In the year 2006, what is the difference between the Cost (current US$) in Minerals and Cost (current US$) in Energy?
Offer a terse response. 3.03e+08. In the year 2006, what is the difference between the Cost (current US$) of Minerals and Cost (current US$) of Forest?
Your response must be concise. -5.59e+08. In the year 2006, what is the difference between the Cost (current US$) of Energy and Cost (current US$) of Forest?
Provide a succinct answer. -8.62e+08. In the year 2007, what is the difference between the Cost (current US$) of CO2 damage and Cost (current US$) of Minerals?
Keep it short and to the point. -4.39e+08. In the year 2007, what is the difference between the Cost (current US$) in CO2 damage and Cost (current US$) in Energy?
Provide a succinct answer. -3.08e+07. In the year 2007, what is the difference between the Cost (current US$) of CO2 damage and Cost (current US$) of Forest?
Provide a succinct answer. -1.39e+09. In the year 2007, what is the difference between the Cost (current US$) in Minerals and Cost (current US$) in Energy?
Ensure brevity in your answer.  4.08e+08. In the year 2007, what is the difference between the Cost (current US$) in Minerals and Cost (current US$) in Forest?
Provide a short and direct response. -9.51e+08. In the year 2007, what is the difference between the Cost (current US$) of Energy and Cost (current US$) of Forest?
Provide a short and direct response. -1.36e+09. In the year 2008, what is the difference between the Cost (current US$) of CO2 damage and Cost (current US$) of Minerals?
Your response must be concise. -6.90e+08. In the year 2008, what is the difference between the Cost (current US$) of CO2 damage and Cost (current US$) of Energy?
Keep it short and to the point. -7.87e+07. In the year 2008, what is the difference between the Cost (current US$) of CO2 damage and Cost (current US$) of Forest?
Your answer should be very brief. -1.72e+09. In the year 2008, what is the difference between the Cost (current US$) in Minerals and Cost (current US$) in Energy?
Provide a short and direct response. 6.11e+08. In the year 2008, what is the difference between the Cost (current US$) in Minerals and Cost (current US$) in Forest?
Provide a short and direct response. -1.03e+09. In the year 2008, what is the difference between the Cost (current US$) in Energy and Cost (current US$) in Forest?
Give a very brief answer. -1.64e+09. In the year 2009, what is the difference between the Cost (current US$) of CO2 damage and Cost (current US$) of Minerals?
Give a very brief answer. -1.07e+09. In the year 2009, what is the difference between the Cost (current US$) of CO2 damage and Cost (current US$) of Energy?
Your response must be concise. -2.28e+07. In the year 2009, what is the difference between the Cost (current US$) in CO2 damage and Cost (current US$) in Forest?
Your answer should be compact. -1.83e+09. In the year 2009, what is the difference between the Cost (current US$) in Minerals and Cost (current US$) in Energy?
Provide a succinct answer. 1.05e+09. In the year 2009, what is the difference between the Cost (current US$) in Minerals and Cost (current US$) in Forest?
Provide a short and direct response. -7.60e+08. In the year 2009, what is the difference between the Cost (current US$) in Energy and Cost (current US$) in Forest?
Your response must be concise. -1.81e+09. In the year 2010, what is the difference between the Cost (current US$) in CO2 damage and Cost (current US$) in Minerals?
Offer a terse response. -1.40e+09. In the year 2010, what is the difference between the Cost (current US$) of CO2 damage and Cost (current US$) of Energy?
Offer a terse response. 2.37e+06. In the year 2010, what is the difference between the Cost (current US$) of CO2 damage and Cost (current US$) of Forest?
Your response must be concise. -1.65e+09. In the year 2010, what is the difference between the Cost (current US$) in Minerals and Cost (current US$) in Energy?
Ensure brevity in your answer.  1.40e+09. In the year 2010, what is the difference between the Cost (current US$) in Minerals and Cost (current US$) in Forest?
Offer a very short reply. -2.51e+08. In the year 2010, what is the difference between the Cost (current US$) in Energy and Cost (current US$) in Forest?
Give a very brief answer. -1.65e+09. In the year 2011, what is the difference between the Cost (current US$) in CO2 damage and Cost (current US$) in Minerals?
Give a very brief answer. -2.01e+09. In the year 2011, what is the difference between the Cost (current US$) in CO2 damage and Cost (current US$) in Energy?
Offer a very short reply. -1.49e+09. In the year 2011, what is the difference between the Cost (current US$) of CO2 damage and Cost (current US$) of Forest?
Keep it short and to the point. -1.93e+09. In the year 2011, what is the difference between the Cost (current US$) in Minerals and Cost (current US$) in Energy?
Offer a very short reply. 5.17e+08. In the year 2011, what is the difference between the Cost (current US$) of Minerals and Cost (current US$) of Forest?
Provide a short and direct response. 8.15e+07. In the year 2011, what is the difference between the Cost (current US$) of Energy and Cost (current US$) of Forest?
Ensure brevity in your answer.  -4.36e+08. In the year 2012, what is the difference between the Cost (current US$) in CO2 damage and Cost (current US$) in Minerals?
Keep it short and to the point. -2.26e+09. In the year 2012, what is the difference between the Cost (current US$) in CO2 damage and Cost (current US$) in Energy?
Ensure brevity in your answer.  -1.11e+09. In the year 2012, what is the difference between the Cost (current US$) in CO2 damage and Cost (current US$) in Forest?
Offer a very short reply. -2.48e+09. In the year 2012, what is the difference between the Cost (current US$) of Minerals and Cost (current US$) of Energy?
Keep it short and to the point. 1.15e+09. In the year 2012, what is the difference between the Cost (current US$) in Minerals and Cost (current US$) in Forest?
Offer a very short reply. -2.19e+08. In the year 2012, what is the difference between the Cost (current US$) in Energy and Cost (current US$) in Forest?
Ensure brevity in your answer.  -1.37e+09. In the year 2013, what is the difference between the Cost (current US$) in CO2 damage and Cost (current US$) in Minerals?
Provide a succinct answer. -1.73e+09. In the year 2013, what is the difference between the Cost (current US$) of CO2 damage and Cost (current US$) of Energy?
Your response must be concise. -1.26e+09. In the year 2013, what is the difference between the Cost (current US$) in CO2 damage and Cost (current US$) in Forest?
Make the answer very short. -2.58e+09. In the year 2013, what is the difference between the Cost (current US$) in Minerals and Cost (current US$) in Energy?
Your answer should be very brief. 4.70e+08. In the year 2013, what is the difference between the Cost (current US$) in Minerals and Cost (current US$) in Forest?
Provide a short and direct response. -8.49e+08. In the year 2013, what is the difference between the Cost (current US$) in Energy and Cost (current US$) in Forest?
Make the answer very short. -1.32e+09. What is the ratio of the Cost (current US$) in CO2 damage in 2006 to that in 2007?
Give a very brief answer. 0.92. What is the ratio of the Cost (current US$) of Minerals in 2006 to that in 2007?
Make the answer very short. 0.79. What is the ratio of the Cost (current US$) of Energy in 2006 to that in 2007?
Offer a very short reply. 0.94. What is the ratio of the Cost (current US$) in Forest in 2006 to that in 2007?
Keep it short and to the point. 0.66. What is the ratio of the Cost (current US$) in CO2 damage in 2006 to that in 2008?
Your answer should be compact. 0.96. What is the ratio of the Cost (current US$) in Minerals in 2006 to that in 2008?
Your answer should be compact. 0.53. What is the ratio of the Cost (current US$) in Energy in 2006 to that in 2008?
Make the answer very short. 0.68. What is the ratio of the Cost (current US$) of Forest in 2006 to that in 2008?
Your answer should be very brief. 0.54. What is the ratio of the Cost (current US$) of CO2 damage in 2006 to that in 2009?
Your answer should be very brief. 1.12. What is the ratio of the Cost (current US$) of Minerals in 2006 to that in 2009?
Your response must be concise. 0.36. What is the ratio of the Cost (current US$) in Energy in 2006 to that in 2009?
Your answer should be very brief. 1.18. What is the ratio of the Cost (current US$) of Forest in 2006 to that in 2009?
Your response must be concise. 0.51. What is the ratio of the Cost (current US$) of CO2 damage in 2006 to that in 2010?
Your response must be concise. 0.83. What is the ratio of the Cost (current US$) of Minerals in 2006 to that in 2010?
Provide a short and direct response. 0.28. What is the ratio of the Cost (current US$) in Energy in 2006 to that in 2010?
Offer a terse response. 1.19. What is the ratio of the Cost (current US$) of Forest in 2006 to that in 2010?
Make the answer very short. 0.56. What is the ratio of the Cost (current US$) in CO2 damage in 2006 to that in 2011?
Your response must be concise. 0.81. What is the ratio of the Cost (current US$) of Minerals in 2006 to that in 2011?
Give a very brief answer. 0.2. What is the ratio of the Cost (current US$) in Energy in 2006 to that in 2011?
Offer a terse response. 0.07. What is the ratio of the Cost (current US$) in Forest in 2006 to that in 2011?
Ensure brevity in your answer.  0.48. What is the ratio of the Cost (current US$) of CO2 damage in 2006 to that in 2012?
Provide a short and direct response. 0.72. What is the ratio of the Cost (current US$) of Minerals in 2006 to that in 2012?
Provide a short and direct response. 0.17. What is the ratio of the Cost (current US$) in Energy in 2006 to that in 2012?
Your answer should be compact. 0.09. What is the ratio of the Cost (current US$) in Forest in 2006 to that in 2012?
Make the answer very short. 0.38. What is the ratio of the Cost (current US$) in CO2 damage in 2006 to that in 2013?
Offer a very short reply. 0.65. What is the ratio of the Cost (current US$) in Minerals in 2006 to that in 2013?
Give a very brief answer. 0.22. What is the ratio of the Cost (current US$) in Energy in 2006 to that in 2013?
Make the answer very short. 0.08. What is the ratio of the Cost (current US$) of Forest in 2006 to that in 2013?
Make the answer very short. 0.36. What is the ratio of the Cost (current US$) in CO2 damage in 2007 to that in 2008?
Keep it short and to the point. 1.04. What is the ratio of the Cost (current US$) of Minerals in 2007 to that in 2008?
Provide a short and direct response. 0.68. What is the ratio of the Cost (current US$) of Energy in 2007 to that in 2008?
Your response must be concise. 0.73. What is the ratio of the Cost (current US$) of Forest in 2007 to that in 2008?
Give a very brief answer. 0.82. What is the ratio of the Cost (current US$) of CO2 damage in 2007 to that in 2009?
Your response must be concise. 1.22. What is the ratio of the Cost (current US$) in Minerals in 2007 to that in 2009?
Offer a terse response. 0.46. What is the ratio of the Cost (current US$) in Energy in 2007 to that in 2009?
Give a very brief answer. 1.25. What is the ratio of the Cost (current US$) in Forest in 2007 to that in 2009?
Make the answer very short. 0.78. What is the ratio of the Cost (current US$) in CO2 damage in 2007 to that in 2010?
Keep it short and to the point. 0.91. What is the ratio of the Cost (current US$) in Minerals in 2007 to that in 2010?
Offer a very short reply. 0.35. What is the ratio of the Cost (current US$) of Energy in 2007 to that in 2010?
Your answer should be very brief. 1.26. What is the ratio of the Cost (current US$) of Forest in 2007 to that in 2010?
Offer a terse response. 0.85. What is the ratio of the Cost (current US$) in CO2 damage in 2007 to that in 2011?
Give a very brief answer. 0.88. What is the ratio of the Cost (current US$) of Minerals in 2007 to that in 2011?
Keep it short and to the point. 0.25. What is the ratio of the Cost (current US$) in Energy in 2007 to that in 2011?
Offer a very short reply. 0.07. What is the ratio of the Cost (current US$) in Forest in 2007 to that in 2011?
Your response must be concise. 0.73. What is the ratio of the Cost (current US$) in CO2 damage in 2007 to that in 2012?
Provide a succinct answer. 0.78. What is the ratio of the Cost (current US$) in Minerals in 2007 to that in 2012?
Give a very brief answer. 0.22. What is the ratio of the Cost (current US$) in Energy in 2007 to that in 2012?
Provide a succinct answer. 0.1. What is the ratio of the Cost (current US$) of Forest in 2007 to that in 2012?
Give a very brief answer. 0.57. What is the ratio of the Cost (current US$) of CO2 damage in 2007 to that in 2013?
Make the answer very short. 0.71. What is the ratio of the Cost (current US$) of Minerals in 2007 to that in 2013?
Offer a terse response. 0.28. What is the ratio of the Cost (current US$) of Energy in 2007 to that in 2013?
Your answer should be compact. 0.08. What is the ratio of the Cost (current US$) of Forest in 2007 to that in 2013?
Provide a succinct answer. 0.55. What is the ratio of the Cost (current US$) of CO2 damage in 2008 to that in 2009?
Provide a succinct answer. 1.16. What is the ratio of the Cost (current US$) of Minerals in 2008 to that in 2009?
Provide a short and direct response. 0.68. What is the ratio of the Cost (current US$) in Energy in 2008 to that in 2009?
Offer a terse response. 1.72. What is the ratio of the Cost (current US$) of Forest in 2008 to that in 2009?
Your response must be concise. 0.95. What is the ratio of the Cost (current US$) in CO2 damage in 2008 to that in 2010?
Provide a succinct answer. 0.87. What is the ratio of the Cost (current US$) of Minerals in 2008 to that in 2010?
Offer a terse response. 0.52. What is the ratio of the Cost (current US$) in Energy in 2008 to that in 2010?
Make the answer very short. 1.74. What is the ratio of the Cost (current US$) of Forest in 2008 to that in 2010?
Keep it short and to the point. 1.04. What is the ratio of the Cost (current US$) of CO2 damage in 2008 to that in 2011?
Give a very brief answer. 0.84. What is the ratio of the Cost (current US$) in Minerals in 2008 to that in 2011?
Keep it short and to the point. 0.37. What is the ratio of the Cost (current US$) of Energy in 2008 to that in 2011?
Ensure brevity in your answer.  0.1. What is the ratio of the Cost (current US$) of Forest in 2008 to that in 2011?
Give a very brief answer. 0.89. What is the ratio of the Cost (current US$) of CO2 damage in 2008 to that in 2012?
Your answer should be very brief. 0.75. What is the ratio of the Cost (current US$) of Minerals in 2008 to that in 2012?
Offer a very short reply. 0.33. What is the ratio of the Cost (current US$) in Energy in 2008 to that in 2012?
Offer a very short reply. 0.13. What is the ratio of the Cost (current US$) of Forest in 2008 to that in 2012?
Make the answer very short. 0.7. What is the ratio of the Cost (current US$) of CO2 damage in 2008 to that in 2013?
Your answer should be compact. 0.68. What is the ratio of the Cost (current US$) in Minerals in 2008 to that in 2013?
Ensure brevity in your answer.  0.42. What is the ratio of the Cost (current US$) of Energy in 2008 to that in 2013?
Your response must be concise. 0.12. What is the ratio of the Cost (current US$) of Forest in 2008 to that in 2013?
Your answer should be very brief. 0.67. What is the ratio of the Cost (current US$) of CO2 damage in 2009 to that in 2010?
Keep it short and to the point. 0.75. What is the ratio of the Cost (current US$) of Minerals in 2009 to that in 2010?
Your answer should be compact. 0.76. What is the ratio of the Cost (current US$) in Energy in 2009 to that in 2010?
Provide a succinct answer. 1.01. What is the ratio of the Cost (current US$) in Forest in 2009 to that in 2010?
Provide a succinct answer. 1.09. What is the ratio of the Cost (current US$) of CO2 damage in 2009 to that in 2011?
Provide a succinct answer. 0.72. What is the ratio of the Cost (current US$) of Minerals in 2009 to that in 2011?
Your answer should be very brief. 0.54. What is the ratio of the Cost (current US$) of Energy in 2009 to that in 2011?
Your response must be concise. 0.06. What is the ratio of the Cost (current US$) of Forest in 2009 to that in 2011?
Your response must be concise. 0.94. What is the ratio of the Cost (current US$) in CO2 damage in 2009 to that in 2012?
Keep it short and to the point. 0.64. What is the ratio of the Cost (current US$) of Minerals in 2009 to that in 2012?
Ensure brevity in your answer.  0.48. What is the ratio of the Cost (current US$) of Energy in 2009 to that in 2012?
Ensure brevity in your answer.  0.08. What is the ratio of the Cost (current US$) of Forest in 2009 to that in 2012?
Your response must be concise. 0.73. What is the ratio of the Cost (current US$) in CO2 damage in 2009 to that in 2013?
Offer a very short reply. 0.59. What is the ratio of the Cost (current US$) of Minerals in 2009 to that in 2013?
Offer a very short reply. 0.62. What is the ratio of the Cost (current US$) of Energy in 2009 to that in 2013?
Your response must be concise. 0.07. What is the ratio of the Cost (current US$) of Forest in 2009 to that in 2013?
Your answer should be compact. 0.7. What is the ratio of the Cost (current US$) of CO2 damage in 2010 to that in 2011?
Give a very brief answer. 0.97. What is the ratio of the Cost (current US$) of Minerals in 2010 to that in 2011?
Your response must be concise. 0.71. What is the ratio of the Cost (current US$) of Energy in 2010 to that in 2011?
Offer a terse response. 0.06. What is the ratio of the Cost (current US$) of Forest in 2010 to that in 2011?
Provide a short and direct response. 0.86. What is the ratio of the Cost (current US$) in CO2 damage in 2010 to that in 2012?
Your response must be concise. 0.86. What is the ratio of the Cost (current US$) in Minerals in 2010 to that in 2012?
Provide a succinct answer. 0.63. What is the ratio of the Cost (current US$) of Energy in 2010 to that in 2012?
Make the answer very short. 0.08. What is the ratio of the Cost (current US$) in Forest in 2010 to that in 2012?
Your response must be concise. 0.67. What is the ratio of the Cost (current US$) in CO2 damage in 2010 to that in 2013?
Make the answer very short. 0.79. What is the ratio of the Cost (current US$) of Minerals in 2010 to that in 2013?
Offer a very short reply. 0.8. What is the ratio of the Cost (current US$) of Energy in 2010 to that in 2013?
Ensure brevity in your answer.  0.07. What is the ratio of the Cost (current US$) of Forest in 2010 to that in 2013?
Your response must be concise. 0.64. What is the ratio of the Cost (current US$) of CO2 damage in 2011 to that in 2012?
Your answer should be compact. 0.89. What is the ratio of the Cost (current US$) of Minerals in 2011 to that in 2012?
Your response must be concise. 0.89. What is the ratio of the Cost (current US$) in Energy in 2011 to that in 2012?
Offer a very short reply. 1.3. What is the ratio of the Cost (current US$) of Forest in 2011 to that in 2012?
Make the answer very short. 0.78. What is the ratio of the Cost (current US$) in CO2 damage in 2011 to that in 2013?
Make the answer very short. 0.81. What is the ratio of the Cost (current US$) of Minerals in 2011 to that in 2013?
Provide a short and direct response. 1.14. What is the ratio of the Cost (current US$) in Energy in 2011 to that in 2013?
Offer a terse response. 1.15. What is the ratio of the Cost (current US$) in Forest in 2011 to that in 2013?
Keep it short and to the point. 0.75. What is the ratio of the Cost (current US$) of CO2 damage in 2012 to that in 2013?
Offer a terse response. 0.91. What is the ratio of the Cost (current US$) in Minerals in 2012 to that in 2013?
Provide a succinct answer. 1.28. What is the ratio of the Cost (current US$) in Energy in 2012 to that in 2013?
Give a very brief answer. 0.88. What is the ratio of the Cost (current US$) of Forest in 2012 to that in 2013?
Make the answer very short. 0.96. What is the difference between the highest and the second highest Cost (current US$) in CO2 damage?
Your response must be concise. 1.11e+07. What is the difference between the highest and the second highest Cost (current US$) of Minerals?
Provide a short and direct response. 2.67e+08. What is the difference between the highest and the second highest Cost (current US$) in Energy?
Ensure brevity in your answer.  2.04e+08. What is the difference between the highest and the second highest Cost (current US$) of Forest?
Offer a very short reply. 1.12e+08. What is the difference between the highest and the lowest Cost (current US$) of CO2 damage?
Ensure brevity in your answer.  5.01e+07. What is the difference between the highest and the lowest Cost (current US$) of Minerals?
Provide a succinct answer. 1.96e+09. What is the difference between the highest and the lowest Cost (current US$) of Energy?
Make the answer very short. 1.49e+09. What is the difference between the highest and the lowest Cost (current US$) in Forest?
Provide a short and direct response. 1.73e+09. 